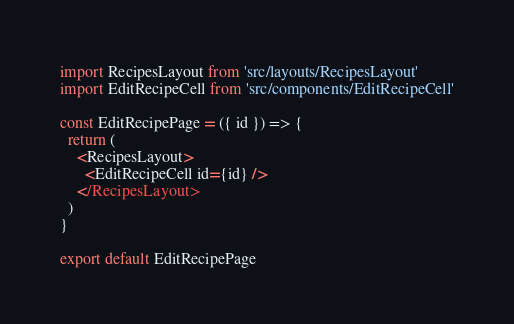Convert code to text. <code><loc_0><loc_0><loc_500><loc_500><_JavaScript_>import RecipesLayout from 'src/layouts/RecipesLayout'
import EditRecipeCell from 'src/components/EditRecipeCell'

const EditRecipePage = ({ id }) => {
  return (
    <RecipesLayout>
      <EditRecipeCell id={id} />
    </RecipesLayout>
  )
}

export default EditRecipePage
</code> 